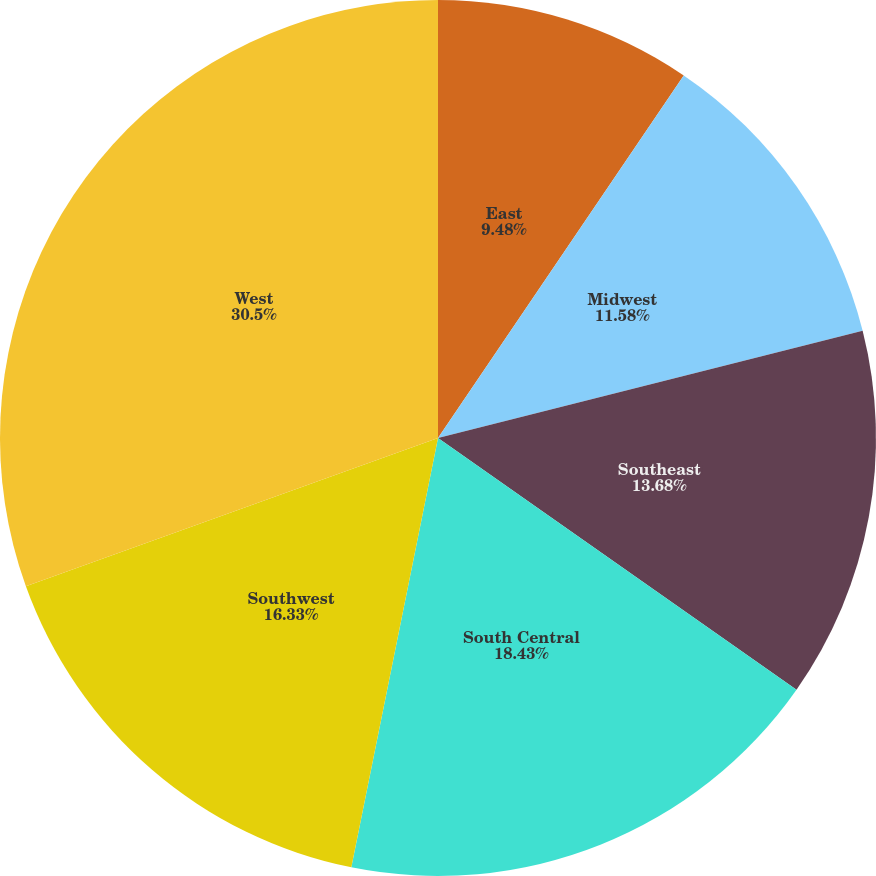Convert chart. <chart><loc_0><loc_0><loc_500><loc_500><pie_chart><fcel>East<fcel>Midwest<fcel>Southeast<fcel>South Central<fcel>Southwest<fcel>West<nl><fcel>9.48%<fcel>11.58%<fcel>13.68%<fcel>18.43%<fcel>16.33%<fcel>30.5%<nl></chart> 